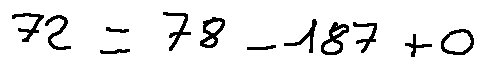<formula> <loc_0><loc_0><loc_500><loc_500>7 2 \pm 7 8 - 1 8 7 + 0</formula> 